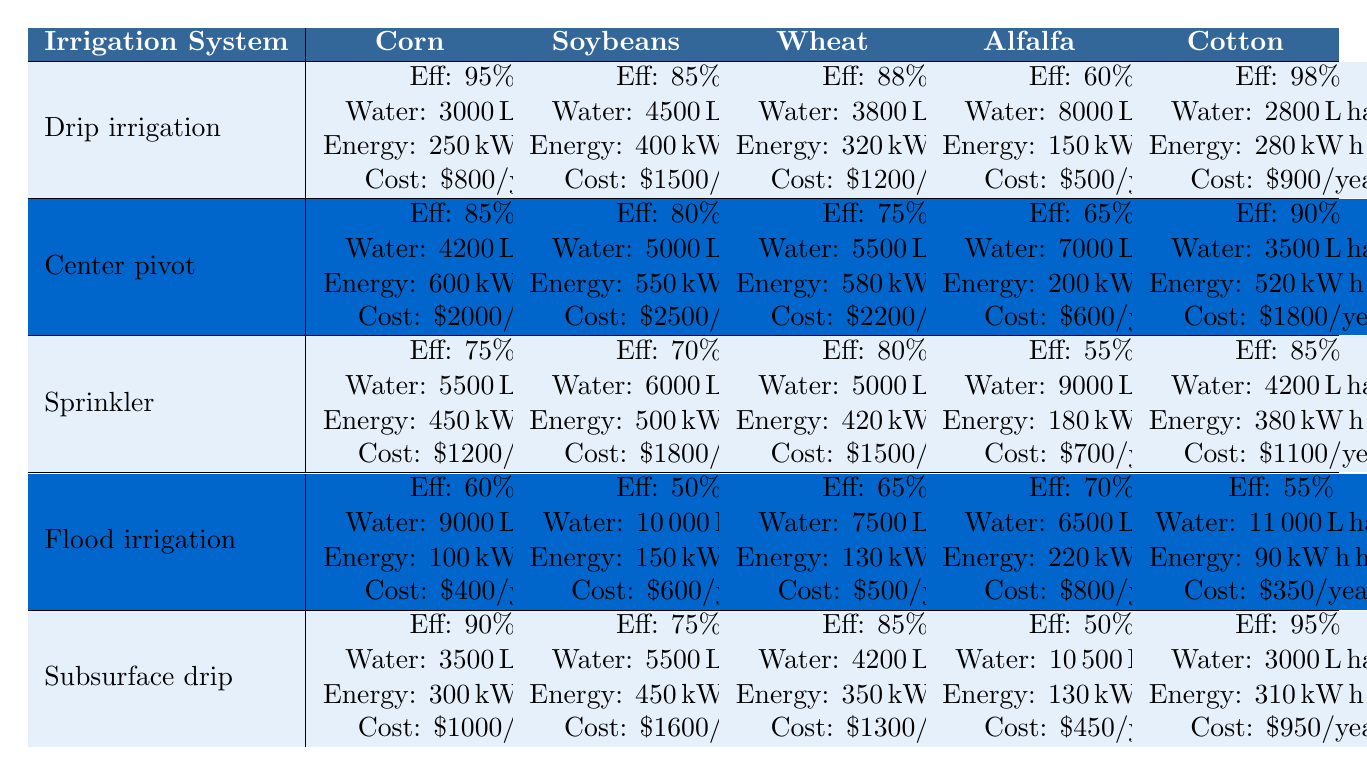What is the efficiency rating of Drip irrigation for Corn? According to the table, the efficiency rating for Drip irrigation when used for Corn is 95%.
Answer: 95% What irrigation system has the highest efficiency for Soybeans? From the table, Drip irrigation has an efficiency rating of 85%, which is the highest among all listed systems for Soybeans.
Answer: Drip irrigation Which crop uses the least amount of water per hectare when irrigated with Flood irrigation? The table shows that Flood irrigation uses 9000 liters per hectare for Corn, 10000 liters for Soybeans, 7500 liters for Wheat, 6500 liters for Alfalfa, and 11000 liters for Cotton. The least water used is 6500 liters for Alfalfa.
Answer: 6500 liters What is the total annual maintenance cost of using Sprinkler irrigation for all crop types? The total cost for Sprinkler irrigation is calculated as follows: $1200 (Corn) + $1800 (Soybeans) + $1500 (Wheat) + $700 (Alfalfa) + $1100 (Cotton) = $5100.
Answer: $5100 Which irrigation system has the lowest energy consumption for Wheat? The table lists energy consumption for Wheat: Drip irrigation at 320 kWh, Center pivot at 580 kWh, Sprinkler at 420 kWh, Flood irrigation at 130 kWh, and Subsurface drip at 350 kWh. The lowest is Flood irrigation at 130 kWh.
Answer: Flood irrigation Is the efficiency rating of Subsurface drip for Cotton greater than 90%? The table shows that Subsurface drip has an efficiency rating of 95% for Cotton, which is indeed greater than 90%.
Answer: Yes What is the average water usage per hectare for all irrigation systems when used for Alfalfa? The water usages for Alfalfa are: 8000 liters (Drip), 7000 liters (Center pivot), 9000 liters (Sprinkler), 6500 liters (Flood), and 10500 liters (Subsurface drip). Summing these gives 8000 + 7000 + 9000 + 6500 + 10500 = 40000 liters. Dividing by 5 gives an average of 8000 liters.
Answer: 8000 liters Which crop has the highest maintenance cost for Center pivot irrigation? The maintenance costs for Center pivot for various crops are $2000 (Corn), $2500 (Soybeans), $2200 (Wheat), $600 (Alfalfa), and $1800 (Cotton). The highest cost is $2500 for Soybeans.
Answer: $2500 What is the difference in efficiency ratings between the best and worst systems for Cotton? The best efficiency rating for Cotton is 98% with Drip irrigation and the worst is 55% with Flood irrigation. The difference is 98% - 55% = 43%.
Answer: 43% Does Sprinkler irrigation use more water for Soybeans than Center pivot irrigation? According to the table, Sprinkler irrigation uses 6000 liters for Soybeans, while Center pivot uses 5000 liters. Sprinkler irrigation does indeed use more.
Answer: Yes 